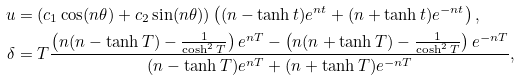<formula> <loc_0><loc_0><loc_500><loc_500>u & = ( c _ { 1 } \cos ( n \theta ) + c _ { 2 } \sin ( n \theta ) ) \left ( ( n - \tanh { t } ) e ^ { n t } + ( n + \tanh { t } ) e ^ { - n t } \right ) , \\ \delta & = T \frac { \left ( n ( n - \tanh { T } ) - \frac { 1 } { \cosh ^ { 2 } { T } } \right ) e ^ { n T } - \left ( n ( n + \tanh { T } ) - \frac { 1 } { \cosh ^ { 2 } { T } } \right ) e ^ { - n T } } { ( n - \tanh { T } ) e ^ { n T } + ( n + \tanh { T } ) e ^ { - n T } } ,</formula> 